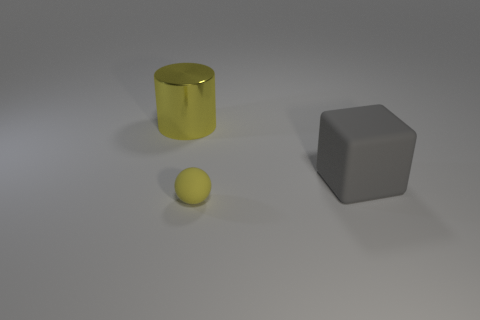There is a yellow object that is right of the yellow object that is behind the big gray rubber block; what is its size?
Offer a very short reply. Small. Is there a thing of the same size as the gray block?
Offer a very short reply. Yes. There is a sphere that is made of the same material as the block; what is its color?
Ensure brevity in your answer.  Yellow. Are there fewer gray rubber blocks than large gray rubber cylinders?
Ensure brevity in your answer.  No. There is a object that is behind the tiny yellow object and on the left side of the big gray matte object; what material is it?
Ensure brevity in your answer.  Metal. Are there any large objects that are on the right side of the yellow object that is in front of the yellow cylinder?
Keep it short and to the point. Yes. What number of cubes are the same color as the sphere?
Ensure brevity in your answer.  0. There is a thing that is the same color as the shiny cylinder; what is it made of?
Ensure brevity in your answer.  Rubber. Is the material of the tiny thing the same as the cylinder?
Make the answer very short. No. Are there any things left of the small yellow matte object?
Make the answer very short. Yes. 